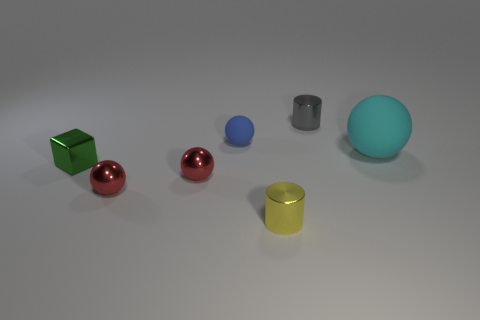Subtract 1 spheres. How many spheres are left? 3 Add 1 big green shiny blocks. How many objects exist? 8 Subtract all blocks. How many objects are left? 6 Subtract 0 purple balls. How many objects are left? 7 Subtract all big red spheres. Subtract all gray shiny cylinders. How many objects are left? 6 Add 2 small green metallic things. How many small green metallic things are left? 3 Add 1 small yellow things. How many small yellow things exist? 2 